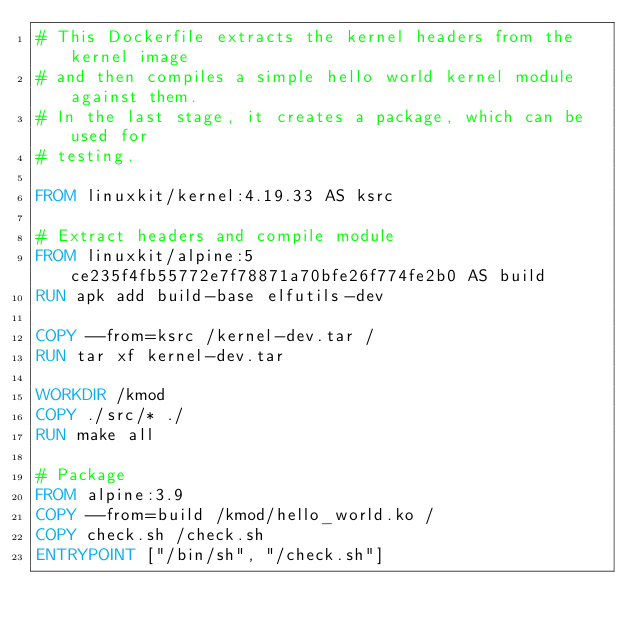Convert code to text. <code><loc_0><loc_0><loc_500><loc_500><_Dockerfile_># This Dockerfile extracts the kernel headers from the kernel image
# and then compiles a simple hello world kernel module against them.
# In the last stage, it creates a package, which can be used for
# testing.

FROM linuxkit/kernel:4.19.33 AS ksrc

# Extract headers and compile module
FROM linuxkit/alpine:5ce235f4fb55772e7f78871a70bfe26f774fe2b0 AS build
RUN apk add build-base elfutils-dev

COPY --from=ksrc /kernel-dev.tar /
RUN tar xf kernel-dev.tar

WORKDIR /kmod
COPY ./src/* ./
RUN make all

# Package
FROM alpine:3.9
COPY --from=build /kmod/hello_world.ko /
COPY check.sh /check.sh
ENTRYPOINT ["/bin/sh", "/check.sh"]
</code> 